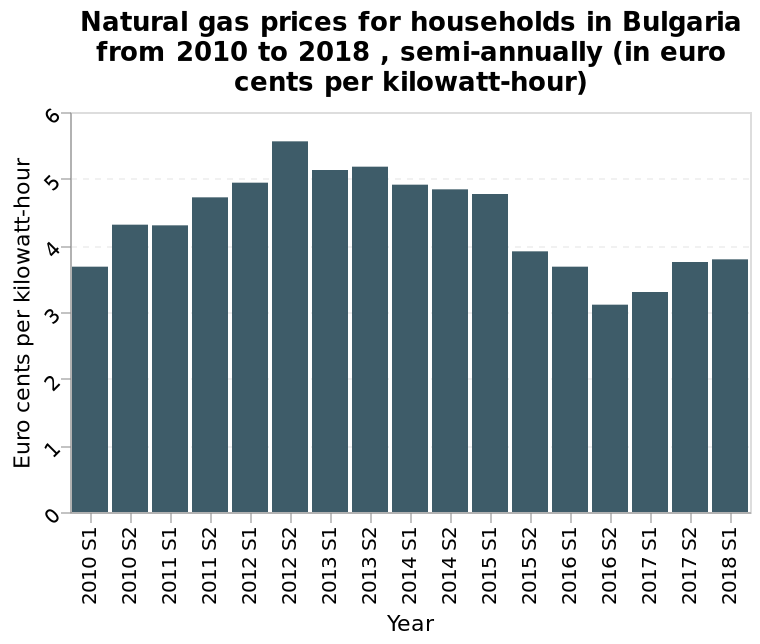<image>
Offer a thorough analysis of the image. The highest rate of gas was in the second half of the year 2012 when it increased from 4.8 to 5.5 cents per kWh.  The lowest rate of 3.3 cents per kWh was in the second half of the year 2016. please enumerates aspects of the construction of the chart Natural gas prices for households in Bulgaria from 2010 to 2018 , semi-annually (in euro cents per kilowatt-hour) is a bar plot. The y-axis measures Euro cents per kilowatt-hour. Year is plotted on the x-axis. Did the prices of natural gas increase or decrease between 2010 S1 and 2012 S2 in Bulgaria? The prices of natural gas increased between 2010 S1 and 2012 S2 in Bulgaria. please summary the statistics and relations of the chart Natural gas increased in price from 2010, peaking in cost in 2012 S2 at 5.5c/KWh. Since then the price has come back to prices similar to the 2010 level at 3.8, including a dip below this in 2016 S2. 